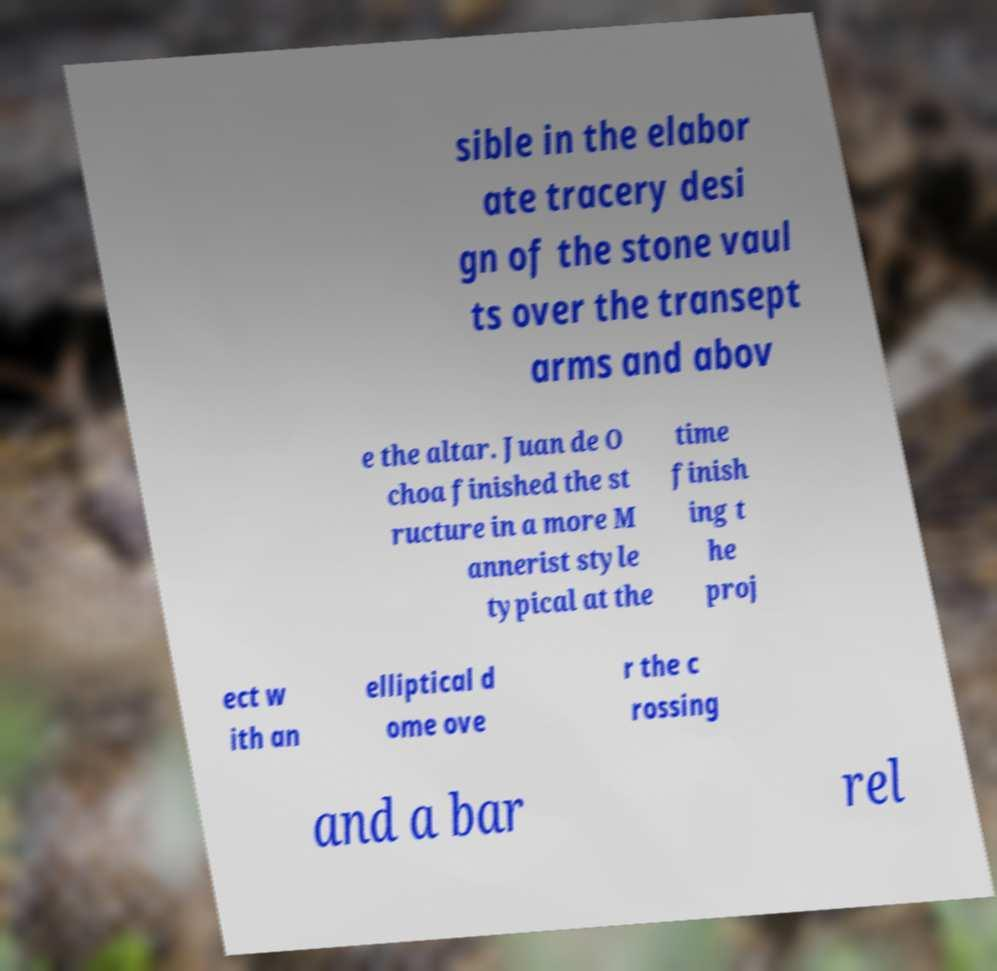Please read and relay the text visible in this image. What does it say? sible in the elabor ate tracery desi gn of the stone vaul ts over the transept arms and abov e the altar. Juan de O choa finished the st ructure in a more M annerist style typical at the time finish ing t he proj ect w ith an elliptical d ome ove r the c rossing and a bar rel 